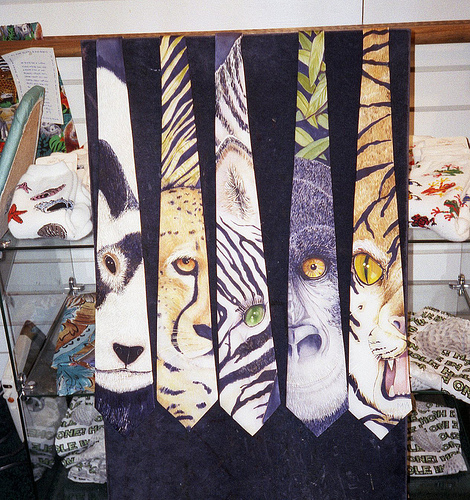These ties look quite artistic. Do you think they are hand-painted or printed? The designs on the ties appear to be quite detailed and artistic, suggesting they could be hand-painted creations, which adds to their uniqueness. However, without closer inspection, it's also possible that they are printed with a hand-painted effect. 